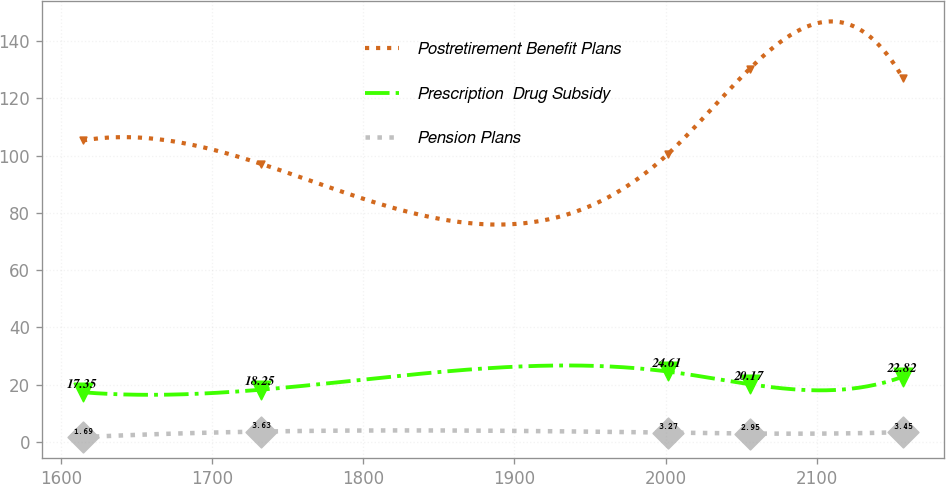<chart> <loc_0><loc_0><loc_500><loc_500><line_chart><ecel><fcel>Postretirement Benefit Plans<fcel>Prescription  Drug Subsidy<fcel>Pension Plans<nl><fcel>1614.33<fcel>105.28<fcel>17.35<fcel>1.69<nl><fcel>1732.14<fcel>97.15<fcel>18.25<fcel>3.63<nl><fcel>2001.33<fcel>100.44<fcel>24.61<fcel>3.27<nl><fcel>2055.62<fcel>130.29<fcel>20.17<fcel>2.95<nl><fcel>2157.2<fcel>127<fcel>22.82<fcel>3.45<nl></chart> 